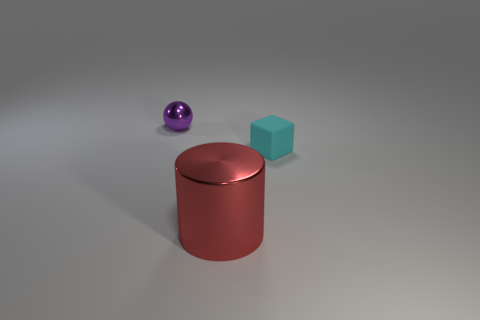Is the number of tiny matte things on the right side of the rubber thing less than the number of small cyan matte cubes that are left of the large metal cylinder?
Your response must be concise. No. There is a tiny purple object; how many red metallic cylinders are in front of it?
Make the answer very short. 1. Does the metal thing in front of the purple shiny object have the same shape as the small thing that is right of the sphere?
Give a very brief answer. No. How many other things are there of the same color as the rubber thing?
Offer a very short reply. 0. There is a tiny object that is to the right of the metal thing right of the small thing behind the tiny cyan block; what is it made of?
Ensure brevity in your answer.  Rubber. What material is the tiny object that is right of the metal thing that is to the left of the large red metallic thing made of?
Give a very brief answer. Rubber. Are there fewer tiny purple objects that are on the right side of the tiny matte thing than yellow metal spheres?
Make the answer very short. No. What is the shape of the shiny object that is right of the tiny purple object?
Your answer should be very brief. Cylinder. There is a cyan cube; is its size the same as the metal object to the right of the tiny sphere?
Make the answer very short. No. Is there another large cylinder made of the same material as the cylinder?
Provide a succinct answer. No. 